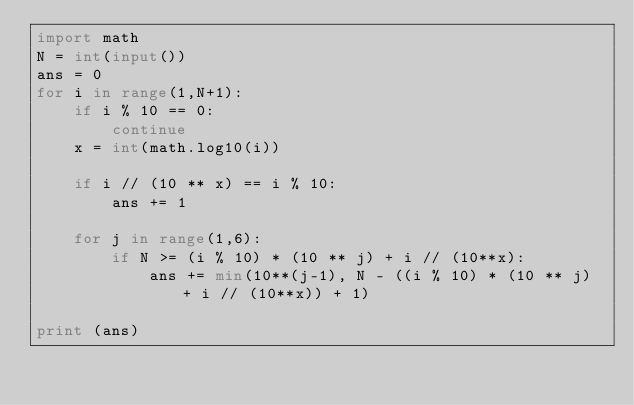Convert code to text. <code><loc_0><loc_0><loc_500><loc_500><_Python_>import math
N = int(input())
ans = 0
for i in range(1,N+1):
    if i % 10 == 0:
        continue
    x = int(math.log10(i))
 
    if i // (10 ** x) == i % 10:  
        ans += 1
    
    for j in range(1,6):
        if N >= (i % 10) * (10 ** j) + i // (10**x):
            ans += min(10**(j-1), N - ((i % 10) * (10 ** j) + i // (10**x)) + 1)

print (ans)</code> 